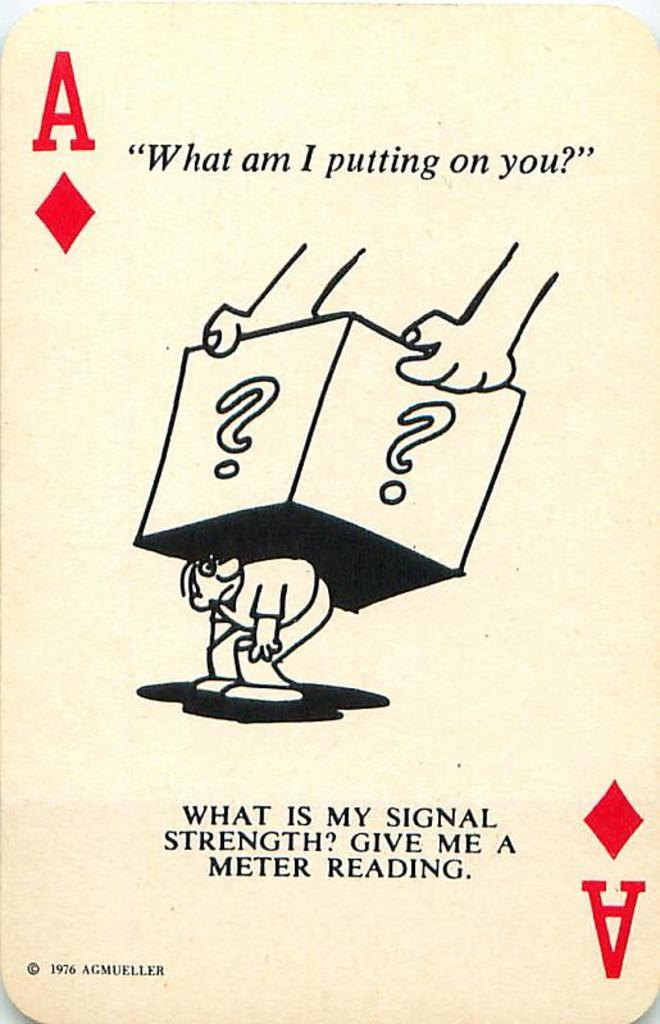<image>
Present a compact description of the photo's key features. An ace card that says what am I putting on you. 